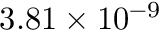<formula> <loc_0><loc_0><loc_500><loc_500>3 . 8 1 \times 1 0 ^ { - 9 }</formula> 